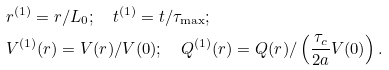Convert formula to latex. <formula><loc_0><loc_0><loc_500><loc_500>& r ^ { ( 1 ) } = r / L _ { 0 } ; \quad t ^ { ( 1 ) } = t / \tau _ { \max } ; \\ & V ^ { ( 1 ) } ( r ) = V ( r ) / V ( 0 ) ; \quad Q ^ { ( 1 ) } ( r ) = Q ( r ) / \left ( \frac { \tau _ { c } } { 2 a } V ( 0 ) \right ) .</formula> 